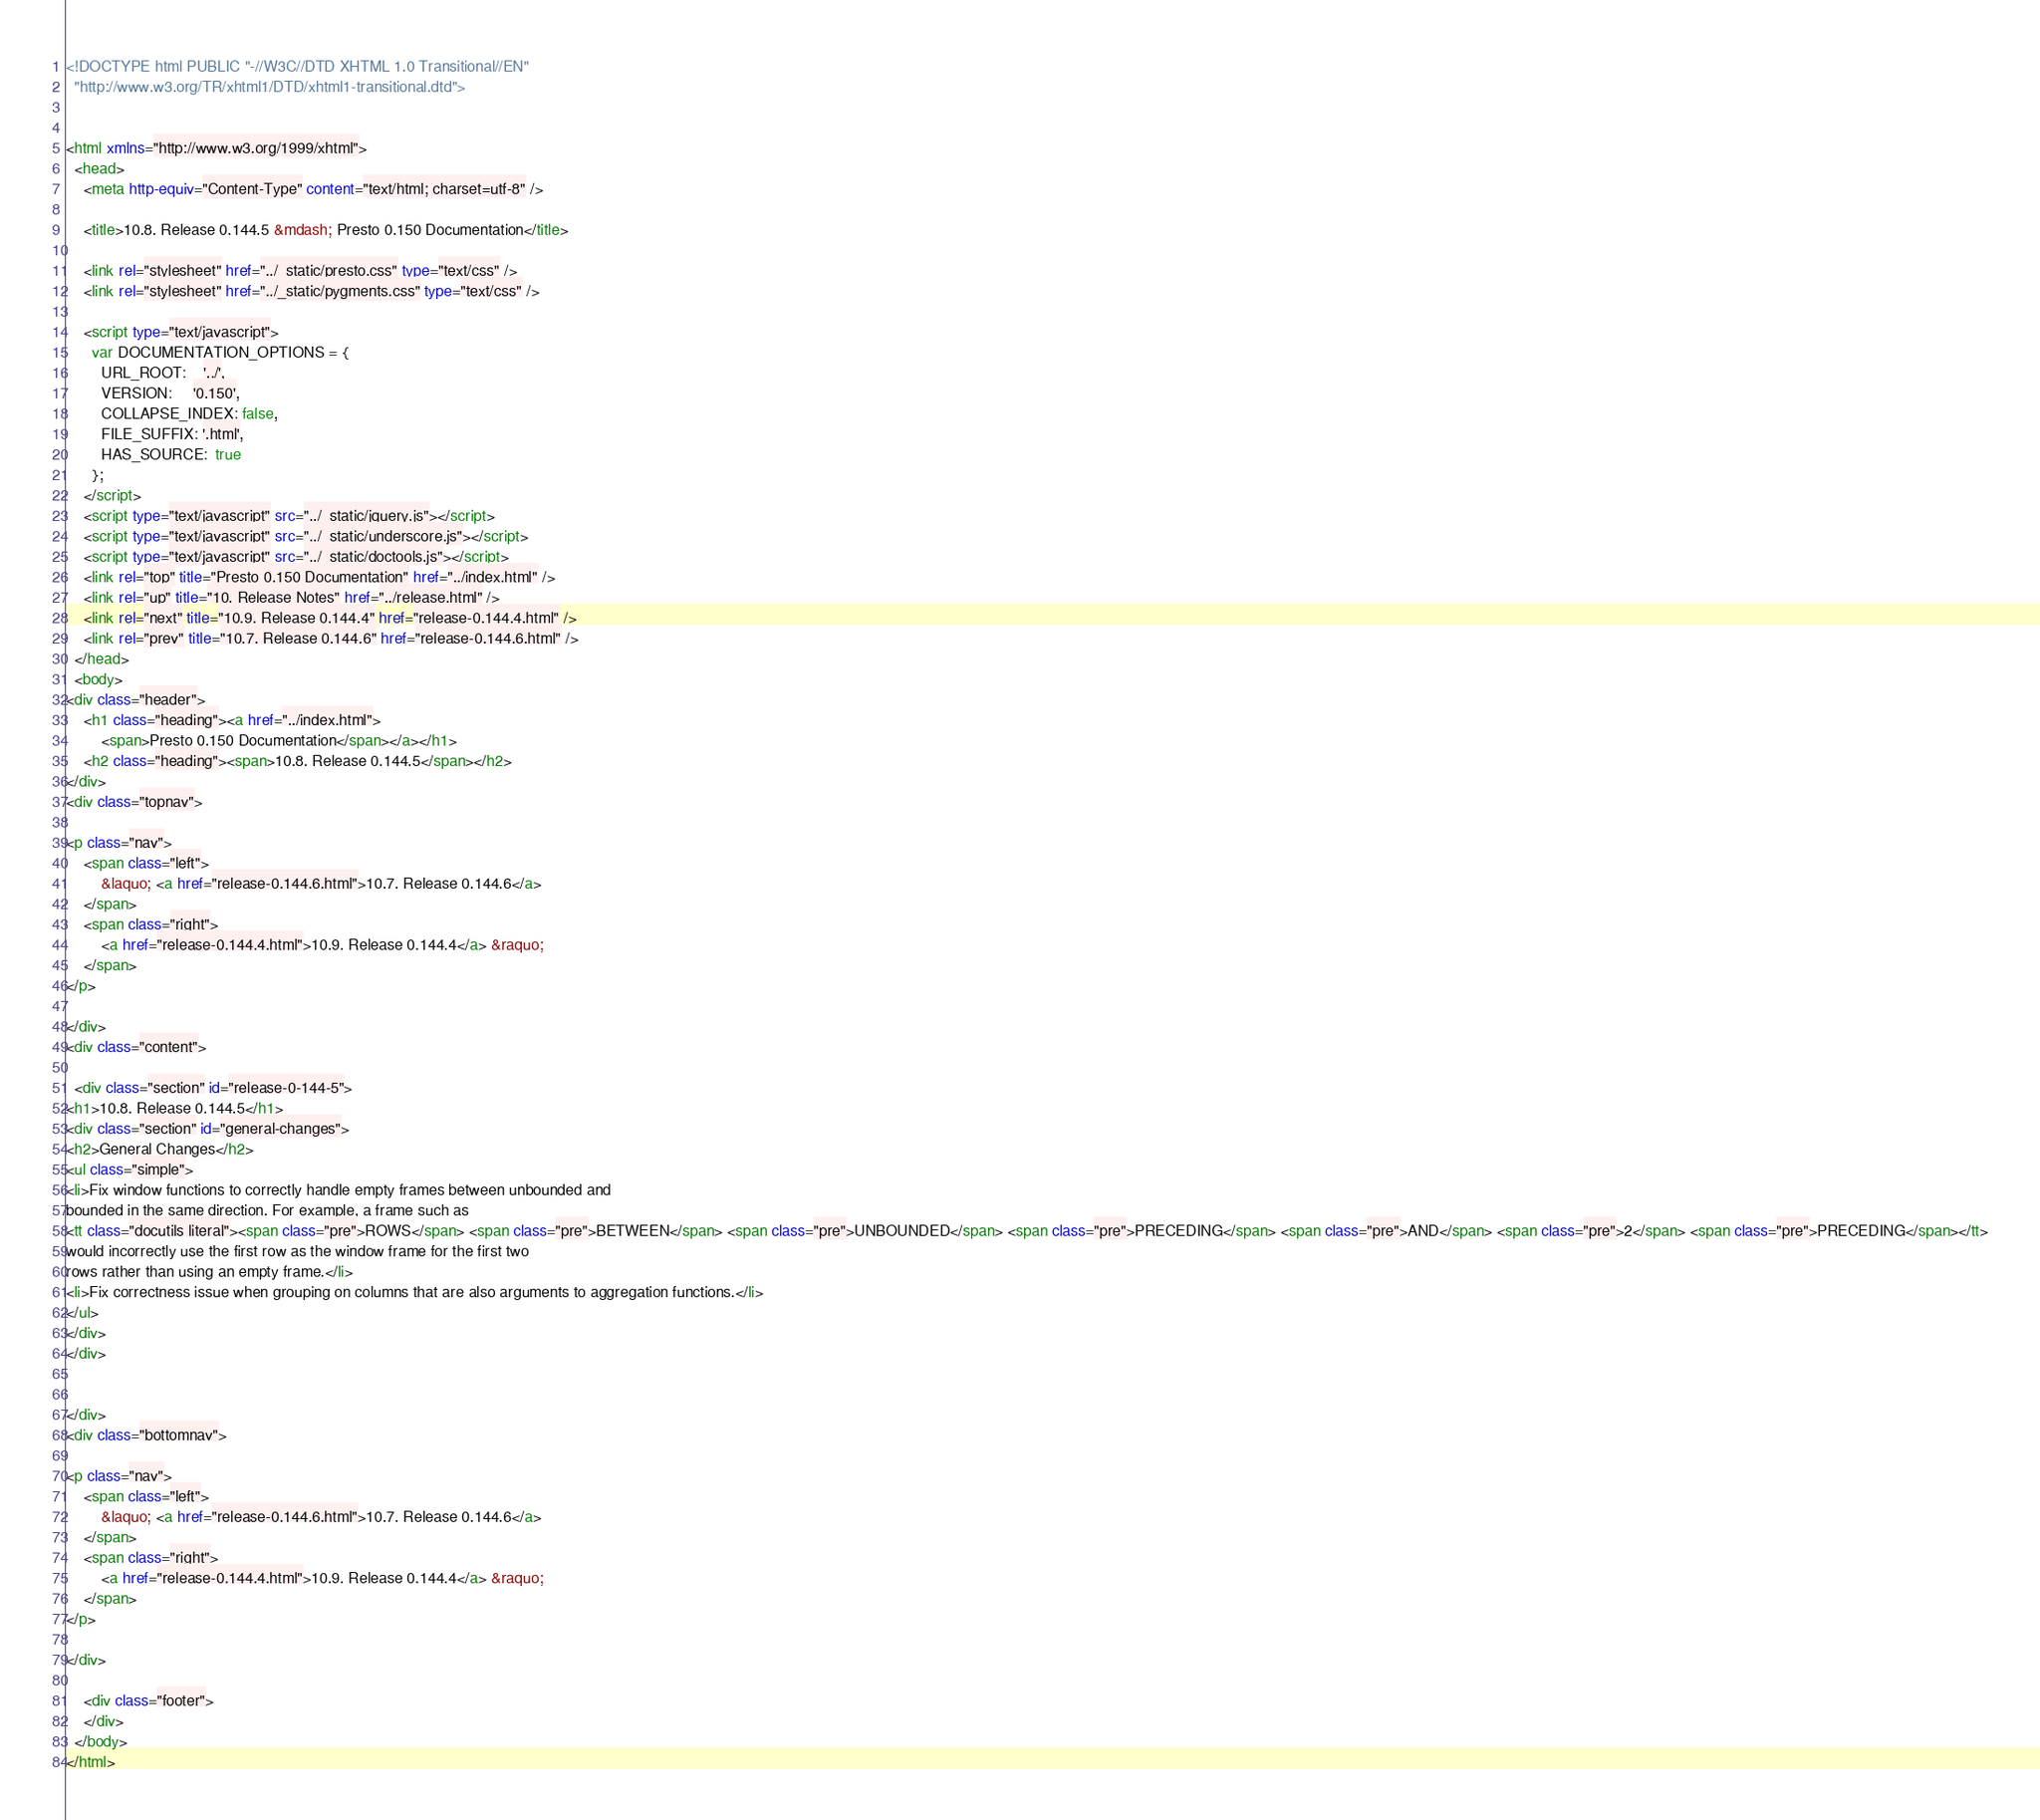Convert code to text. <code><loc_0><loc_0><loc_500><loc_500><_HTML_>
<!DOCTYPE html PUBLIC "-//W3C//DTD XHTML 1.0 Transitional//EN"
  "http://www.w3.org/TR/xhtml1/DTD/xhtml1-transitional.dtd">


<html xmlns="http://www.w3.org/1999/xhtml">
  <head>
    <meta http-equiv="Content-Type" content="text/html; charset=utf-8" />
    
    <title>10.8. Release 0.144.5 &mdash; Presto 0.150 Documentation</title>
    
    <link rel="stylesheet" href="../_static/presto.css" type="text/css" />
    <link rel="stylesheet" href="../_static/pygments.css" type="text/css" />
    
    <script type="text/javascript">
      var DOCUMENTATION_OPTIONS = {
        URL_ROOT:    '../',
        VERSION:     '0.150',
        COLLAPSE_INDEX: false,
        FILE_SUFFIX: '.html',
        HAS_SOURCE:  true
      };
    </script>
    <script type="text/javascript" src="../_static/jquery.js"></script>
    <script type="text/javascript" src="../_static/underscore.js"></script>
    <script type="text/javascript" src="../_static/doctools.js"></script>
    <link rel="top" title="Presto 0.150 Documentation" href="../index.html" />
    <link rel="up" title="10. Release Notes" href="../release.html" />
    <link rel="next" title="10.9. Release 0.144.4" href="release-0.144.4.html" />
    <link rel="prev" title="10.7. Release 0.144.6" href="release-0.144.6.html" /> 
  </head>
  <body>
<div class="header">
    <h1 class="heading"><a href="../index.html">
        <span>Presto 0.150 Documentation</span></a></h1>
    <h2 class="heading"><span>10.8. Release 0.144.5</span></h2>
</div>
<div class="topnav">
    
<p class="nav">
    <span class="left">
        &laquo; <a href="release-0.144.6.html">10.7. Release 0.144.6</a>
    </span>
    <span class="right">
        <a href="release-0.144.4.html">10.9. Release 0.144.4</a> &raquo;
    </span>
</p>

</div>
<div class="content">
    
  <div class="section" id="release-0-144-5">
<h1>10.8. Release 0.144.5</h1>
<div class="section" id="general-changes">
<h2>General Changes</h2>
<ul class="simple">
<li>Fix window functions to correctly handle empty frames between unbounded and
bounded in the same direction. For example, a frame such as
<tt class="docutils literal"><span class="pre">ROWS</span> <span class="pre">BETWEEN</span> <span class="pre">UNBOUNDED</span> <span class="pre">PRECEDING</span> <span class="pre">AND</span> <span class="pre">2</span> <span class="pre">PRECEDING</span></tt>
would incorrectly use the first row as the window frame for the first two
rows rather than using an empty frame.</li>
<li>Fix correctness issue when grouping on columns that are also arguments to aggregation functions.</li>
</ul>
</div>
</div>


</div>
<div class="bottomnav">
    
<p class="nav">
    <span class="left">
        &laquo; <a href="release-0.144.6.html">10.7. Release 0.144.6</a>
    </span>
    <span class="right">
        <a href="release-0.144.4.html">10.9. Release 0.144.4</a> &raquo;
    </span>
</p>

</div>

    <div class="footer">
    </div>
  </body>
</html></code> 